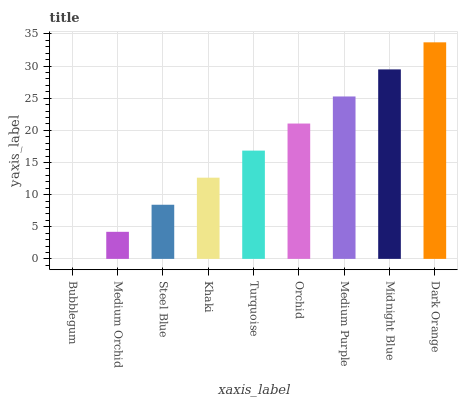Is Bubblegum the minimum?
Answer yes or no. Yes. Is Dark Orange the maximum?
Answer yes or no. Yes. Is Medium Orchid the minimum?
Answer yes or no. No. Is Medium Orchid the maximum?
Answer yes or no. No. Is Medium Orchid greater than Bubblegum?
Answer yes or no. Yes. Is Bubblegum less than Medium Orchid?
Answer yes or no. Yes. Is Bubblegum greater than Medium Orchid?
Answer yes or no. No. Is Medium Orchid less than Bubblegum?
Answer yes or no. No. Is Turquoise the high median?
Answer yes or no. Yes. Is Turquoise the low median?
Answer yes or no. Yes. Is Khaki the high median?
Answer yes or no. No. Is Khaki the low median?
Answer yes or no. No. 